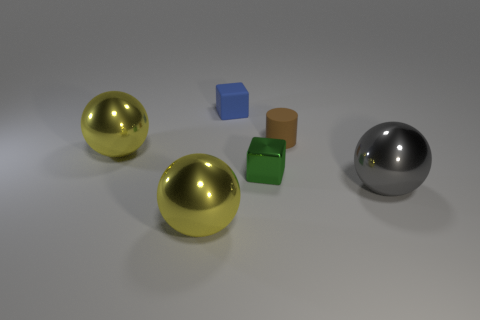The big sphere that is in front of the shiny object on the right side of the matte object that is in front of the matte block is what color?
Provide a succinct answer. Yellow. How many things are metallic spheres on the left side of the small cylinder or tiny green cubes?
Give a very brief answer. 3. What is the material of the other blue cube that is the same size as the metal block?
Your response must be concise. Rubber. What material is the yellow sphere left of the big yellow metal sphere that is in front of the cube in front of the tiny brown matte cylinder?
Offer a very short reply. Metal. What color is the tiny cylinder?
Offer a very short reply. Brown. How many big things are either gray things or matte cubes?
Ensure brevity in your answer.  1. Is the material of the big yellow object that is in front of the green thing the same as the small brown object on the left side of the gray ball?
Give a very brief answer. No. Are there any small red shiny spheres?
Provide a succinct answer. No. Are there more big gray metallic objects that are in front of the small green object than metal things that are on the left side of the small blue block?
Ensure brevity in your answer.  No. There is a blue object that is the same shape as the green thing; what is its material?
Your response must be concise. Rubber. 